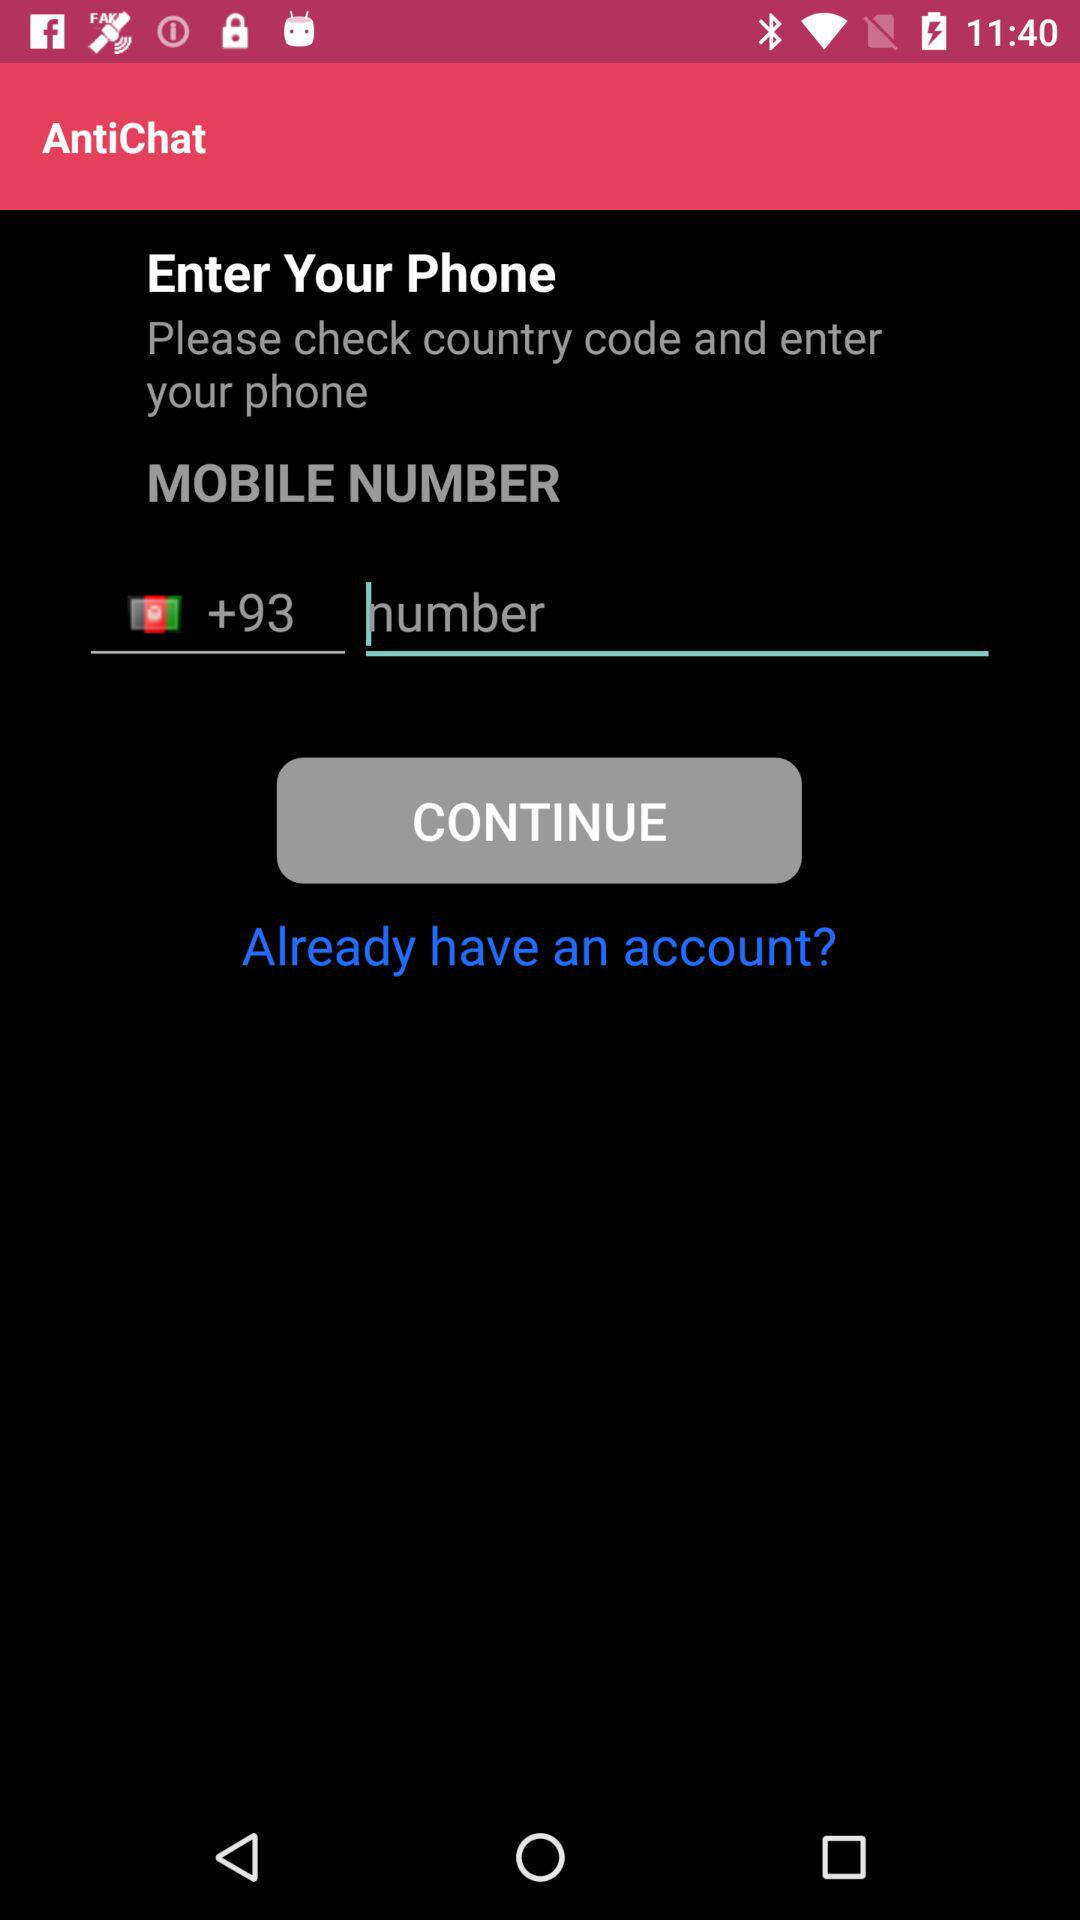What is the version of "AntiChat"?
When the provided information is insufficient, respond with <no answer>. <no answer> 